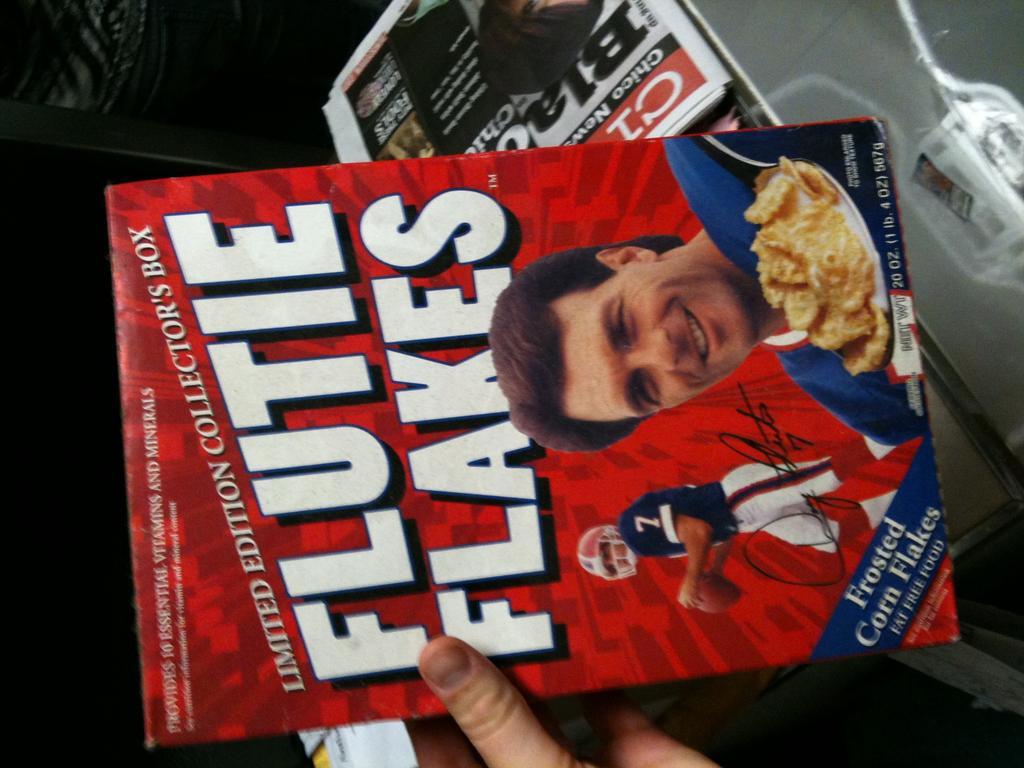In one or two sentences, can you explain what this image depicts? In the picture we can see a person's hand holding a magazine on it, we can see a name Flutie flake and a person's image on it and behind it we can see some magazines are placed on the table. 